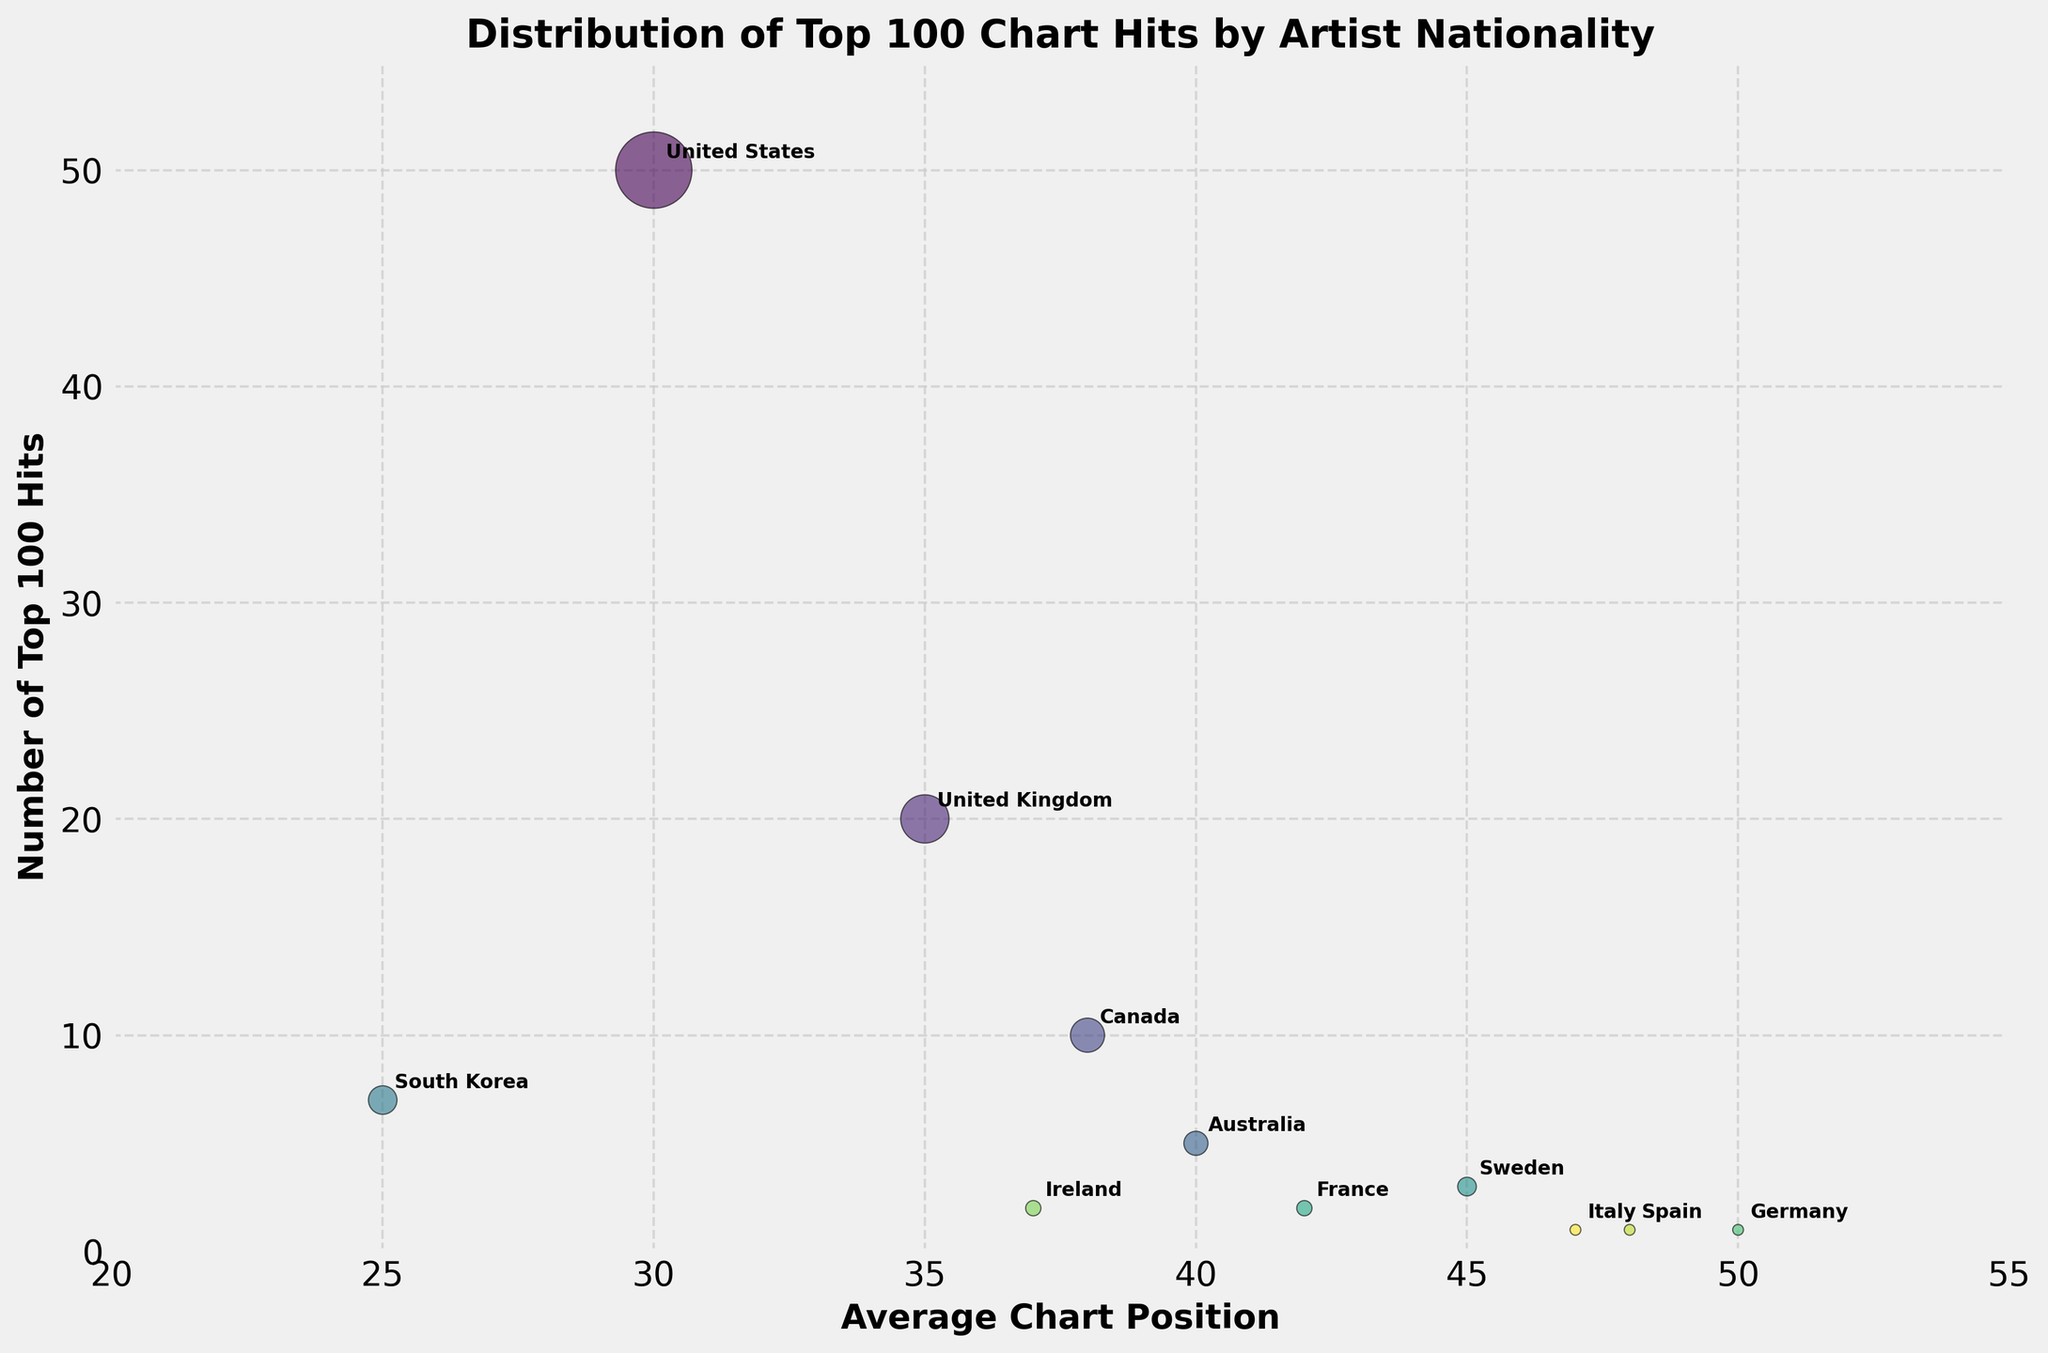what is the title of the chart? The title can be clearly seen at the top of the chart. It reads "Distribution of Top 100 Chart Hits by Artist Nationality"
Answer: Distribution of Top 100 Chart Hits by Artist Nationality How many artist nationalities are represented in the chart? By counting the unique labels annotated in the chart, we see artist nationalities from 11 different countries are represented.
Answer: 11 Which artist nationality has the highest number of Top 100 hits? The largest bubble in the chart corresponds to the United States, with 50 Top 100 hits.
Answer: United States What's the average chart position for artists from South Korea? The South Korea label is annotated on the chart, and it aligns with an average chart position of 25.
Answer: 25 Which country has the smallest bubble on the chart? By observing the smallest bubble, we can see it corresponds to Germany with 1 Top 100 hit.
Answer: Germany Compare the average chart position of artists from Canada to that of the United Kingdom. Which is better? The average chart position for Canada is 38, while for the United Kingdom it is 35. A lower number indicates a better chart position, so the United Kingdom has a better average chart position.
Answer: United Kingdom What are the axis labels on the chart? The x-axis is labeled 'Average Chart Position', and the y-axis is labeled 'Number of Top 100 Hits', as seen on the chart.
Answer: 'Average Chart Position' and 'Number of Top 100 Hits' What is the total number of Top 100 hits from non-English speaking countries? Sum the number of hits for South Korea (7), Sweden (3), France (2), Germany (1), Spain (1), and Italy (1): 7 + 3 + 2 + 1 + 1 + 1 = 15.
Answer: 15 Which artists have an average chart position worse than 40? France (42), Sweden (45), Spain (48), and Italy (47) have an average chart position worse than 40.
Answer: France, Sweden, Spain, Italy What is the average number of Top 100 hits for all the artist nationalities represented? Sum the total number of Top 100 hits and divide by the number of nationalities (50+20+10+5+7+3+2+1+2+1+1 = 102; 102/11 = 9.27).
Answer: 9.27 